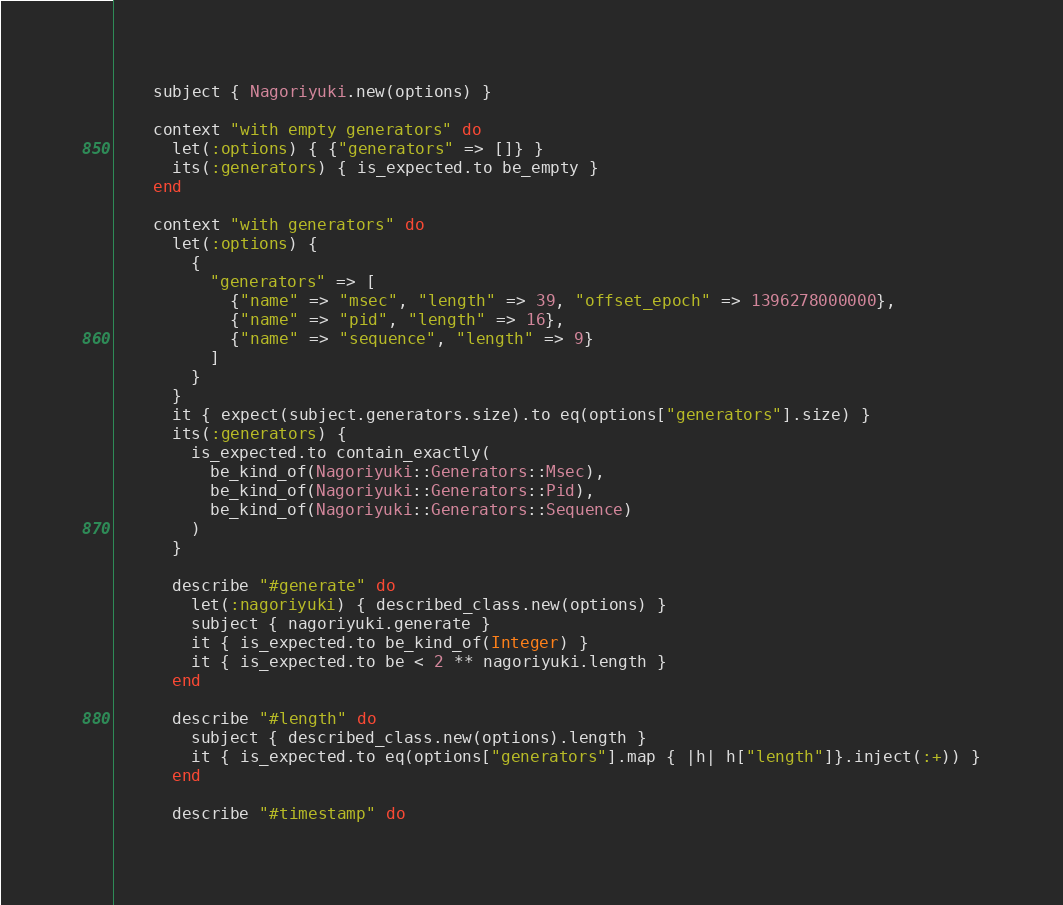Convert code to text. <code><loc_0><loc_0><loc_500><loc_500><_Ruby_>    subject { Nagoriyuki.new(options) }

    context "with empty generators" do
      let(:options) { {"generators" => []} }
      its(:generators) { is_expected.to be_empty }
    end

    context "with generators" do
      let(:options) {
        {
          "generators" => [
            {"name" => "msec", "length" => 39, "offset_epoch" => 1396278000000},
            {"name" => "pid", "length" => 16},
            {"name" => "sequence", "length" => 9}
          ]
        }
      }
      it { expect(subject.generators.size).to eq(options["generators"].size) }
      its(:generators) {
        is_expected.to contain_exactly(
          be_kind_of(Nagoriyuki::Generators::Msec),
          be_kind_of(Nagoriyuki::Generators::Pid),
          be_kind_of(Nagoriyuki::Generators::Sequence)
        )
      }

      describe "#generate" do
        let(:nagoriyuki) { described_class.new(options) }
        subject { nagoriyuki.generate }
        it { is_expected.to be_kind_of(Integer) }
        it { is_expected.to be < 2 ** nagoriyuki.length }
      end

      describe "#length" do
        subject { described_class.new(options).length }
        it { is_expected.to eq(options["generators"].map { |h| h["length"]}.inject(:+)) }
      end

      describe "#timestamp" do</code> 